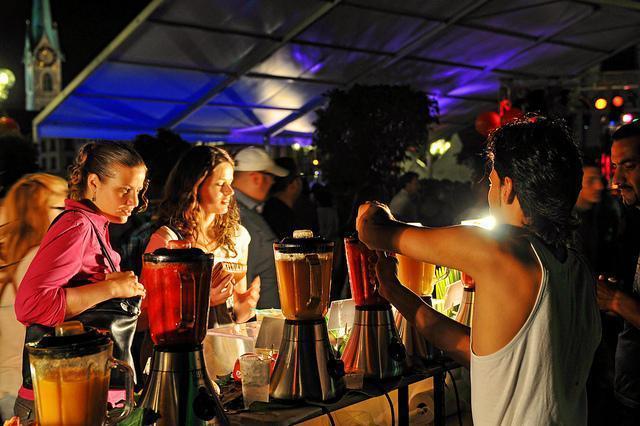How many blenders are visible?
Give a very brief answer. 5. How many people are in the photo?
Give a very brief answer. 6. How many boats can be seen?
Give a very brief answer. 0. 